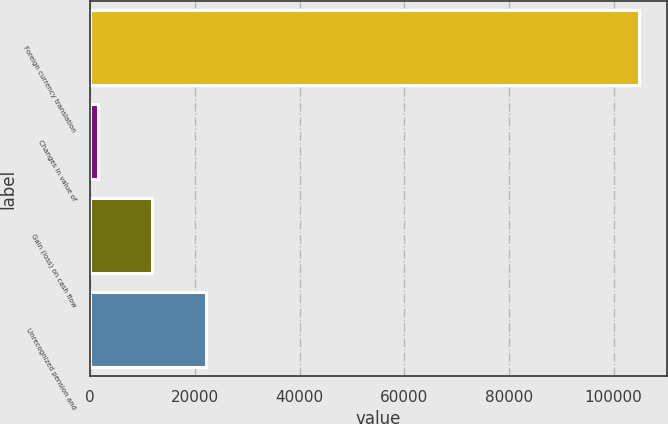<chart> <loc_0><loc_0><loc_500><loc_500><bar_chart><fcel>Foreign currency translation<fcel>Changes in value of<fcel>Gain (loss) on cash flow<fcel>Unrecognized pension and<nl><fcel>104872<fcel>1489<fcel>11827.3<fcel>22165.6<nl></chart> 